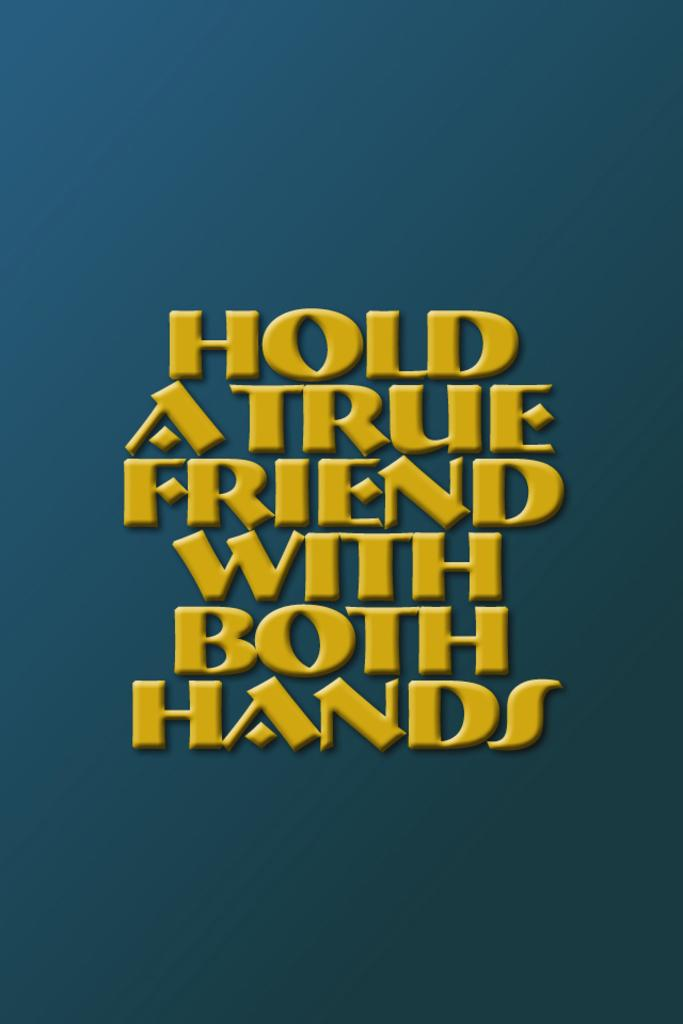<image>
Write a terse but informative summary of the picture. A blue sign that says Hold a True Friend With Both Hands in yellow text. 